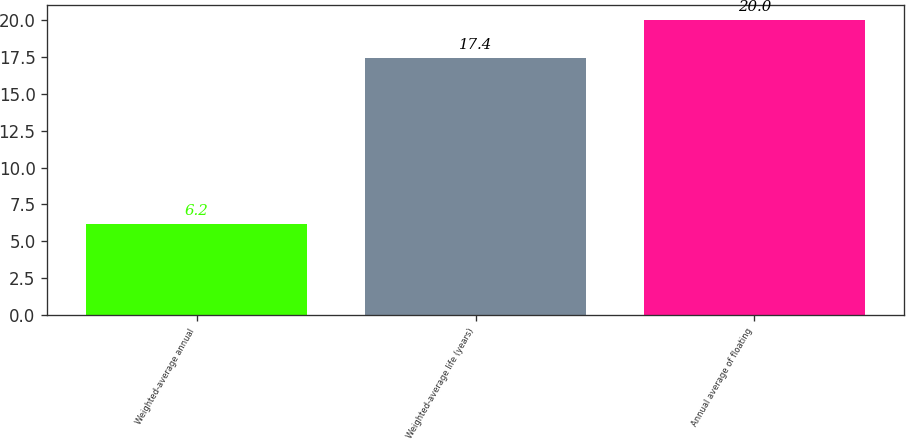Convert chart. <chart><loc_0><loc_0><loc_500><loc_500><bar_chart><fcel>Weighted-average annual<fcel>Weighted-average life (years)<fcel>Annual average of floating<nl><fcel>6.2<fcel>17.4<fcel>20<nl></chart> 